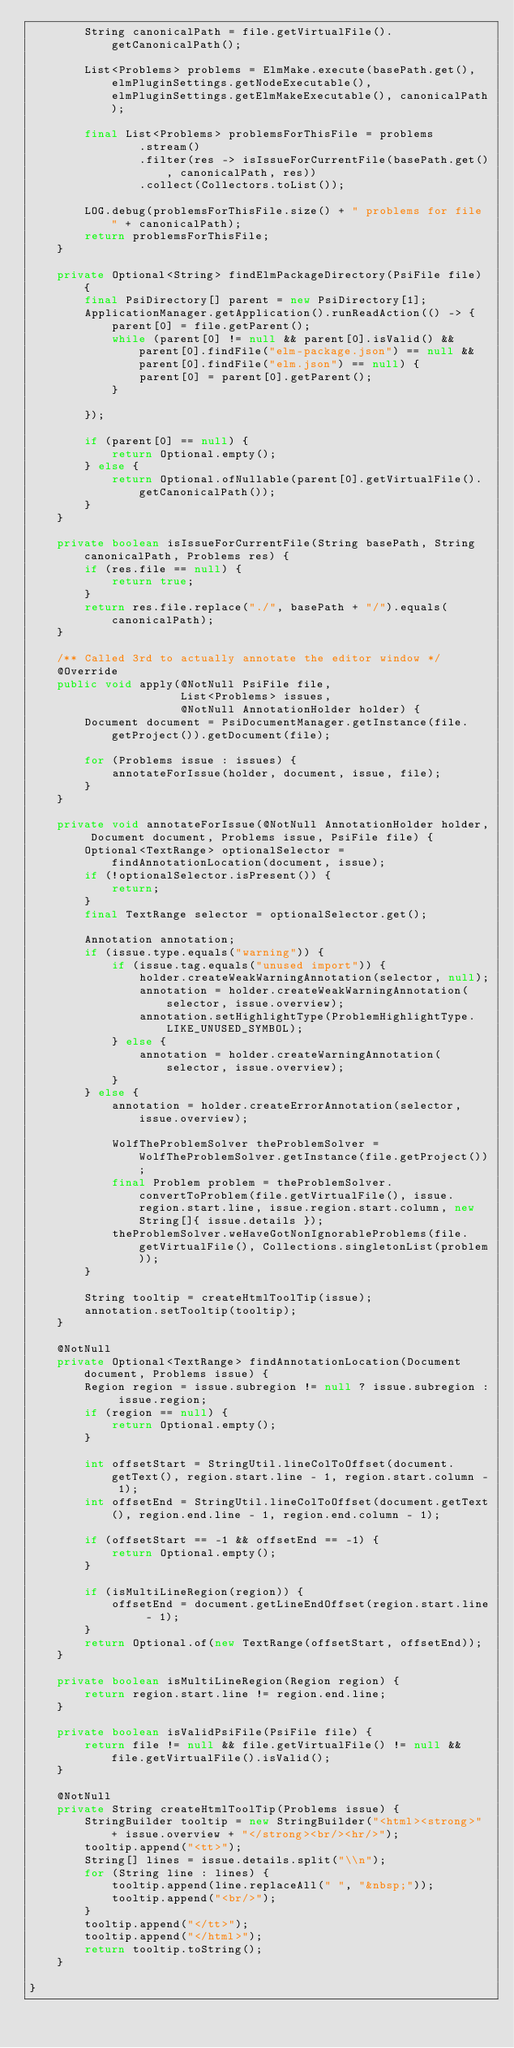Convert code to text. <code><loc_0><loc_0><loc_500><loc_500><_Java_>        String canonicalPath = file.getVirtualFile().getCanonicalPath();

        List<Problems> problems = ElmMake.execute(basePath.get(), elmPluginSettings.getNodeExecutable(), elmPluginSettings.getElmMakeExecutable(), canonicalPath);

        final List<Problems> problemsForThisFile = problems
                .stream()
                .filter(res -> isIssueForCurrentFile(basePath.get(), canonicalPath, res))
                .collect(Collectors.toList());

        LOG.debug(problemsForThisFile.size() + " problems for file " + canonicalPath);
        return problemsForThisFile;
    }

    private Optional<String> findElmPackageDirectory(PsiFile file) {
        final PsiDirectory[] parent = new PsiDirectory[1];
        ApplicationManager.getApplication().runReadAction(() -> {
            parent[0] = file.getParent();
            while (parent[0] != null && parent[0].isValid() && parent[0].findFile("elm-package.json") == null && parent[0].findFile("elm.json") == null) {
                parent[0] = parent[0].getParent();
            }

        });

        if (parent[0] == null) {
            return Optional.empty();
        } else {
            return Optional.ofNullable(parent[0].getVirtualFile().getCanonicalPath());
        }
    }

    private boolean isIssueForCurrentFile(String basePath, String canonicalPath, Problems res) {
        if (res.file == null) {
            return true;
        }
        return res.file.replace("./", basePath + "/").equals(canonicalPath);
    }

    /** Called 3rd to actually annotate the editor window */
    @Override
    public void apply(@NotNull PsiFile file,
                      List<Problems> issues,
                      @NotNull AnnotationHolder holder) {
        Document document = PsiDocumentManager.getInstance(file.getProject()).getDocument(file);

        for (Problems issue : issues) {
            annotateForIssue(holder, document, issue, file);
        }
    }

    private void annotateForIssue(@NotNull AnnotationHolder holder, Document document, Problems issue, PsiFile file) {
        Optional<TextRange> optionalSelector = findAnnotationLocation(document, issue);
        if (!optionalSelector.isPresent()) {
            return;
        }
        final TextRange selector = optionalSelector.get();

        Annotation annotation;
        if (issue.type.equals("warning")) {
            if (issue.tag.equals("unused import")) {
                holder.createWeakWarningAnnotation(selector, null);
                annotation = holder.createWeakWarningAnnotation(selector, issue.overview);
                annotation.setHighlightType(ProblemHighlightType.LIKE_UNUSED_SYMBOL);
            } else {
                annotation = holder.createWarningAnnotation(selector, issue.overview);
            }
        } else {
            annotation = holder.createErrorAnnotation(selector, issue.overview);

            WolfTheProblemSolver theProblemSolver = WolfTheProblemSolver.getInstance(file.getProject());
            final Problem problem = theProblemSolver.convertToProblem(file.getVirtualFile(), issue.region.start.line, issue.region.start.column, new String[]{ issue.details });
            theProblemSolver.weHaveGotNonIgnorableProblems(file.getVirtualFile(), Collections.singletonList(problem));
        }

        String tooltip = createHtmlToolTip(issue);
        annotation.setTooltip(tooltip);
    }

    @NotNull
    private Optional<TextRange> findAnnotationLocation(Document document, Problems issue) {
        Region region = issue.subregion != null ? issue.subregion : issue.region;
        if (region == null) {
            return Optional.empty();
        }

        int offsetStart = StringUtil.lineColToOffset(document.getText(), region.start.line - 1, region.start.column - 1);
        int offsetEnd = StringUtil.lineColToOffset(document.getText(), region.end.line - 1, region.end.column - 1);

        if (offsetStart == -1 && offsetEnd == -1) {
            return Optional.empty();
        }

        if (isMultiLineRegion(region)) {
            offsetEnd = document.getLineEndOffset(region.start.line - 1);
        }
        return Optional.of(new TextRange(offsetStart, offsetEnd));
    }

    private boolean isMultiLineRegion(Region region) {
        return region.start.line != region.end.line;
    }

    private boolean isValidPsiFile(PsiFile file) {
        return file != null && file.getVirtualFile() != null && file.getVirtualFile().isValid();
    }

    @NotNull
    private String createHtmlToolTip(Problems issue) {
        StringBuilder tooltip = new StringBuilder("<html><strong>" + issue.overview + "</strong><br/><hr/>");
        tooltip.append("<tt>");
        String[] lines = issue.details.split("\\n");
        for (String line : lines) {
            tooltip.append(line.replaceAll(" ", "&nbsp;"));
            tooltip.append("<br/>");
        }
        tooltip.append("</tt>");
        tooltip.append("</html>");
        return tooltip.toString();
    }

}

</code> 